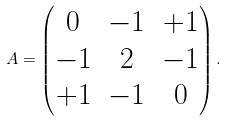<formula> <loc_0><loc_0><loc_500><loc_500>A = \begin{pmatrix} 0 & - 1 & + 1 \\ - 1 & 2 & - 1 \\ + 1 & - 1 & 0 \end{pmatrix} .</formula> 